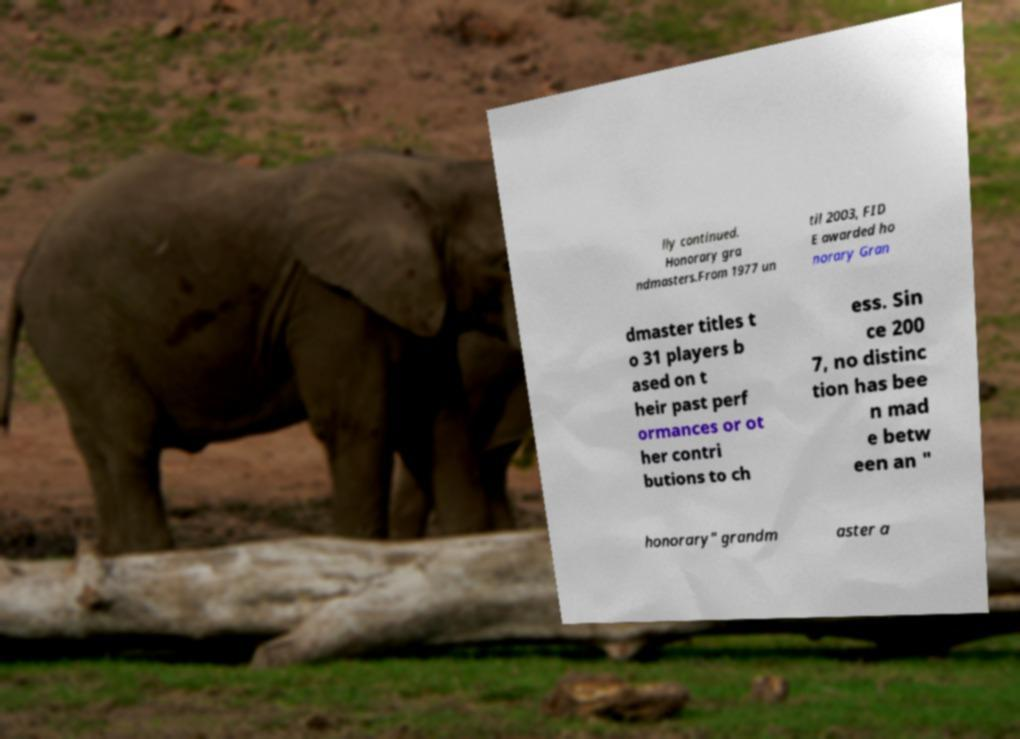I need the written content from this picture converted into text. Can you do that? lly continued. Honorary gra ndmasters.From 1977 un til 2003, FID E awarded ho norary Gran dmaster titles t o 31 players b ased on t heir past perf ormances or ot her contri butions to ch ess. Sin ce 200 7, no distinc tion has bee n mad e betw een an " honorary" grandm aster a 